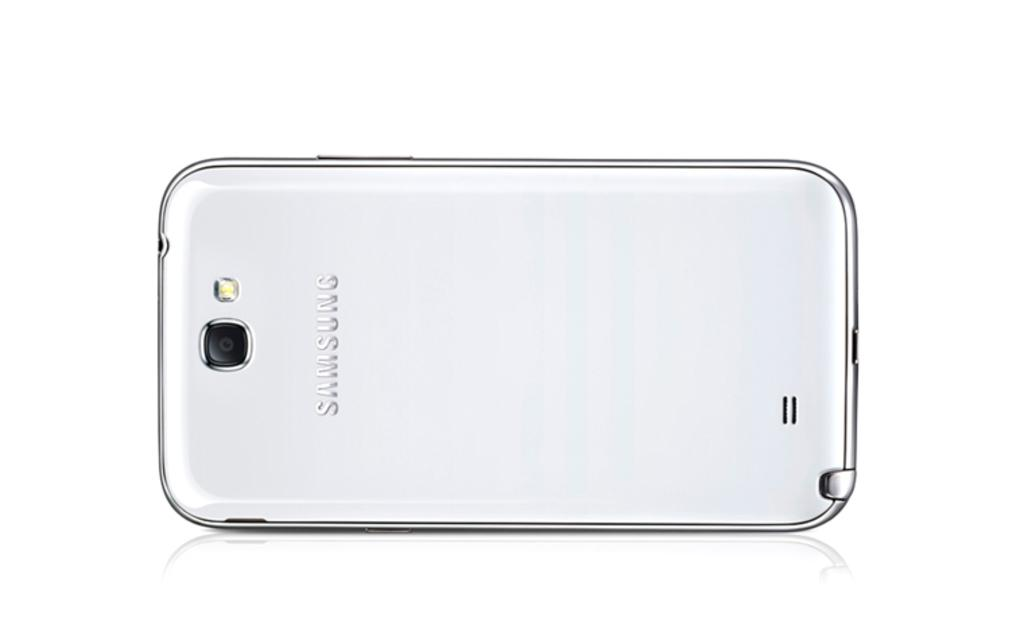<image>
Create a compact narrative representing the image presented. the sideways backside of a silver samsung phone 